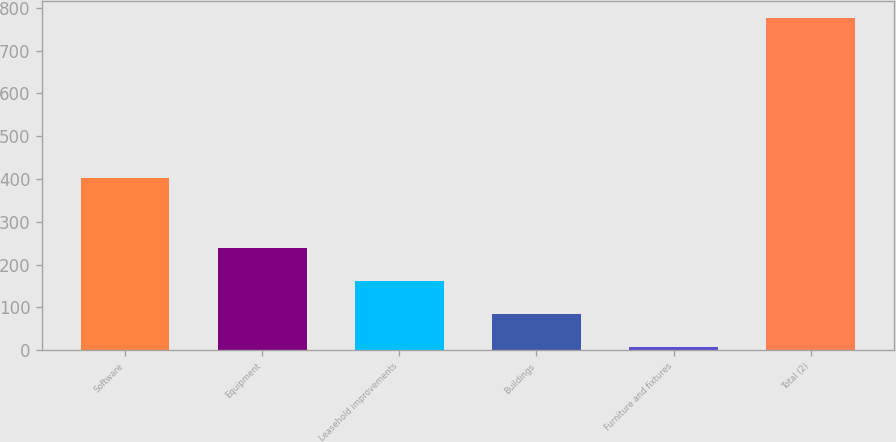Convert chart. <chart><loc_0><loc_0><loc_500><loc_500><bar_chart><fcel>Software<fcel>Equipment<fcel>Leasehold improvements<fcel>Buildings<fcel>Furniture and fixtures<fcel>Total (2)<nl><fcel>403<fcel>238<fcel>161<fcel>84<fcel>7<fcel>777<nl></chart> 